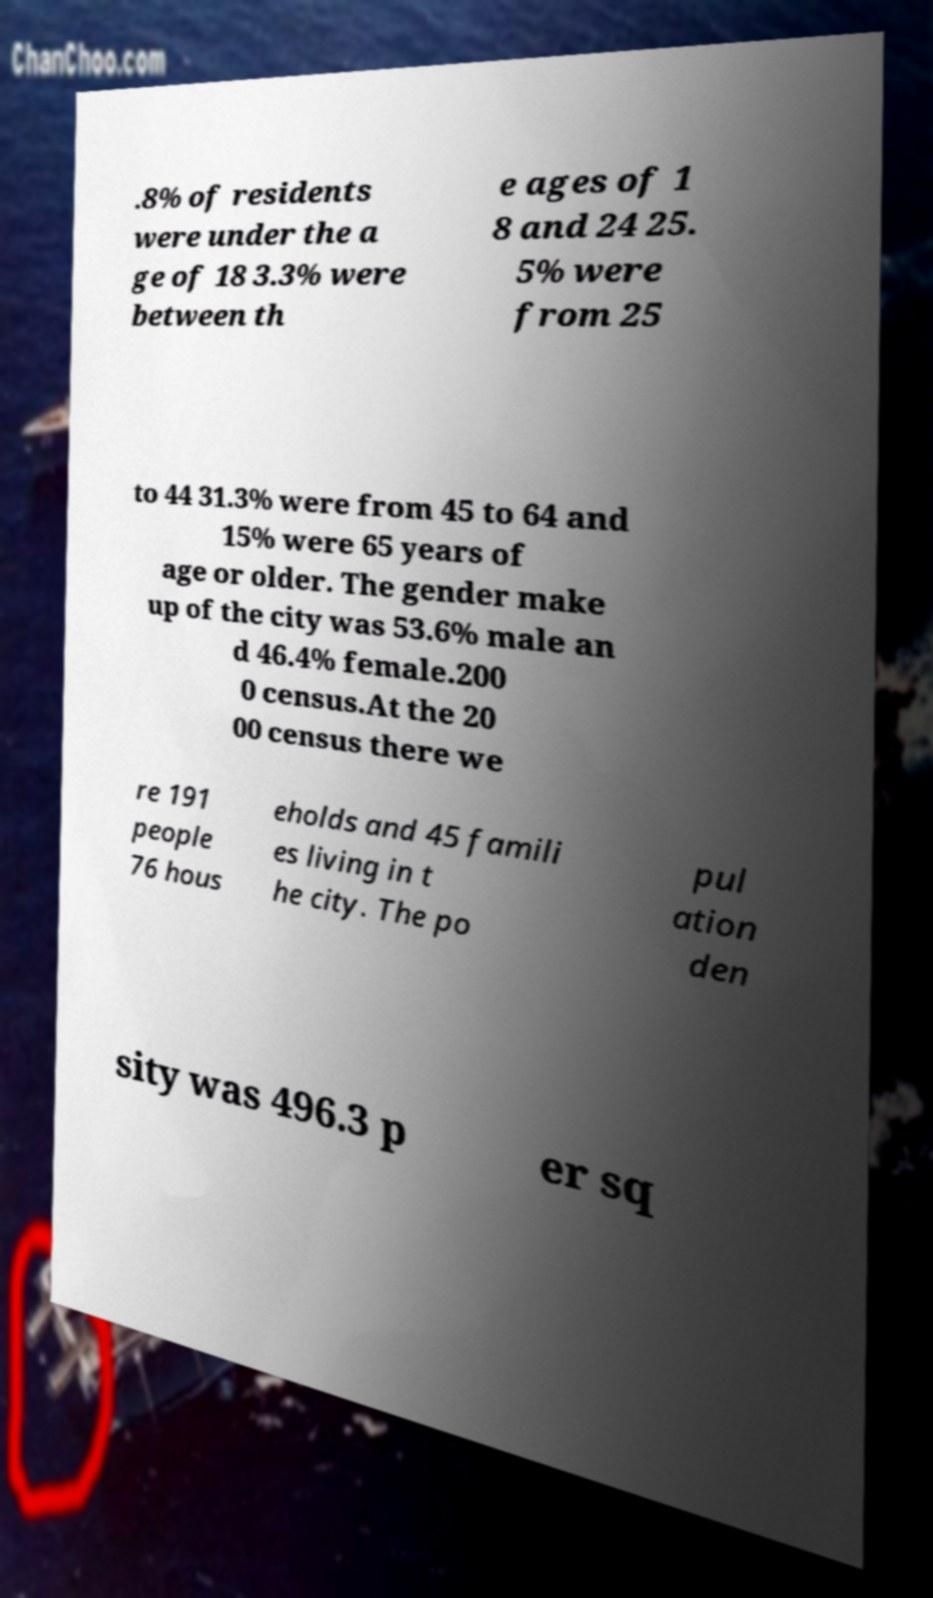What messages or text are displayed in this image? I need them in a readable, typed format. .8% of residents were under the a ge of 18 3.3% were between th e ages of 1 8 and 24 25. 5% were from 25 to 44 31.3% were from 45 to 64 and 15% were 65 years of age or older. The gender make up of the city was 53.6% male an d 46.4% female.200 0 census.At the 20 00 census there we re 191 people 76 hous eholds and 45 famili es living in t he city. The po pul ation den sity was 496.3 p er sq 